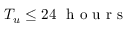<formula> <loc_0><loc_0><loc_500><loc_500>T _ { u } \leq 2 4 \ h o u r s</formula> 